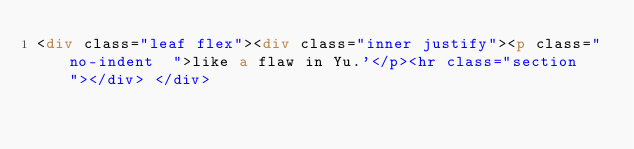<code> <loc_0><loc_0><loc_500><loc_500><_HTML_><div class="leaf flex"><div class="inner justify"><p class="no-indent  ">like a flaw in Yu.'</p><hr class="section"></div> </div></code> 